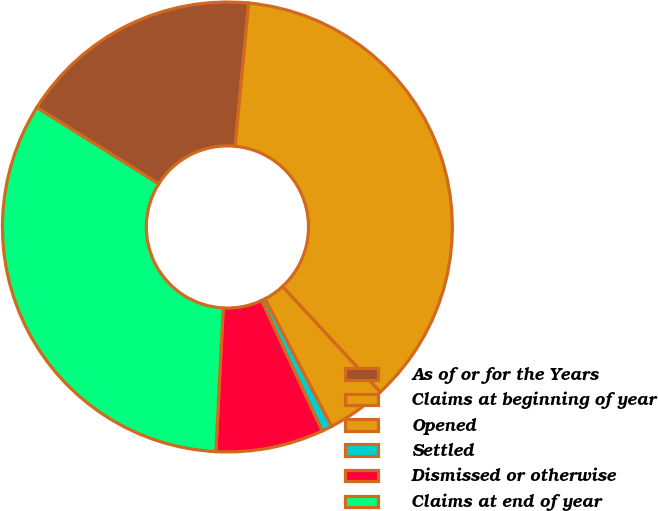Convert chart. <chart><loc_0><loc_0><loc_500><loc_500><pie_chart><fcel>As of or for the Years<fcel>Claims at beginning of year<fcel>Opened<fcel>Settled<fcel>Dismissed or otherwise<fcel>Claims at end of year<nl><fcel>17.6%<fcel>36.61%<fcel>4.23%<fcel>0.73%<fcel>7.74%<fcel>33.1%<nl></chart> 